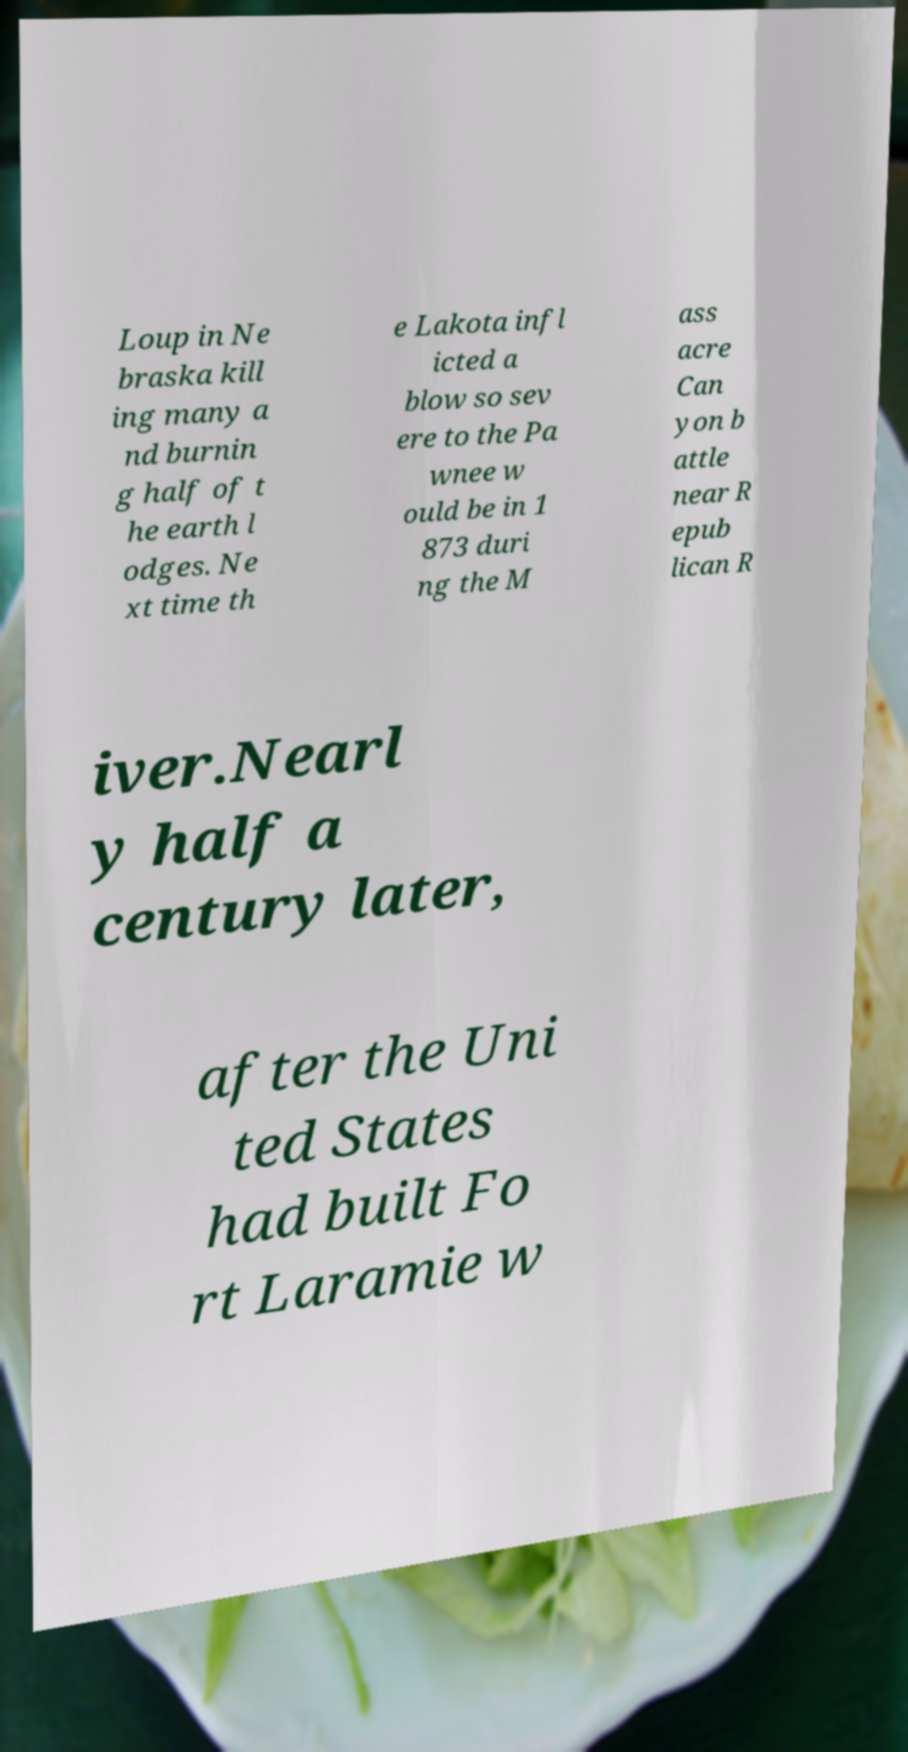What messages or text are displayed in this image? I need them in a readable, typed format. Loup in Ne braska kill ing many a nd burnin g half of t he earth l odges. Ne xt time th e Lakota infl icted a blow so sev ere to the Pa wnee w ould be in 1 873 duri ng the M ass acre Can yon b attle near R epub lican R iver.Nearl y half a century later, after the Uni ted States had built Fo rt Laramie w 